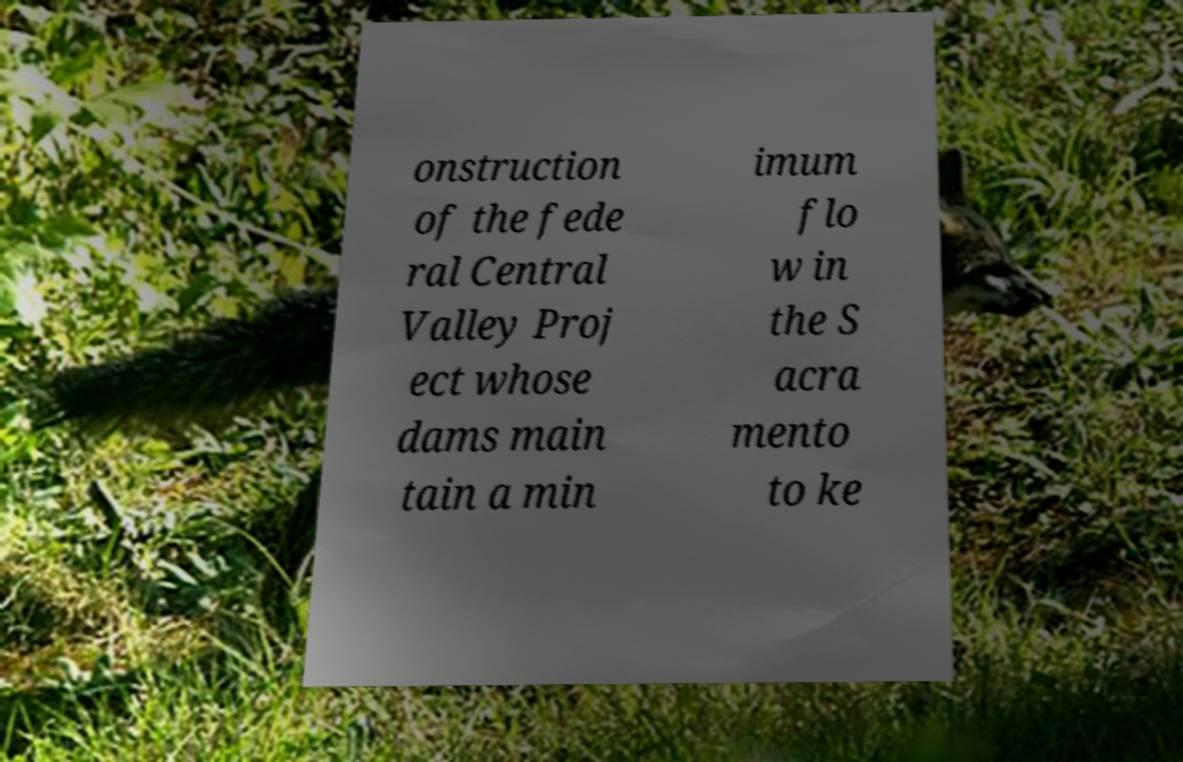Could you assist in decoding the text presented in this image and type it out clearly? onstruction of the fede ral Central Valley Proj ect whose dams main tain a min imum flo w in the S acra mento to ke 